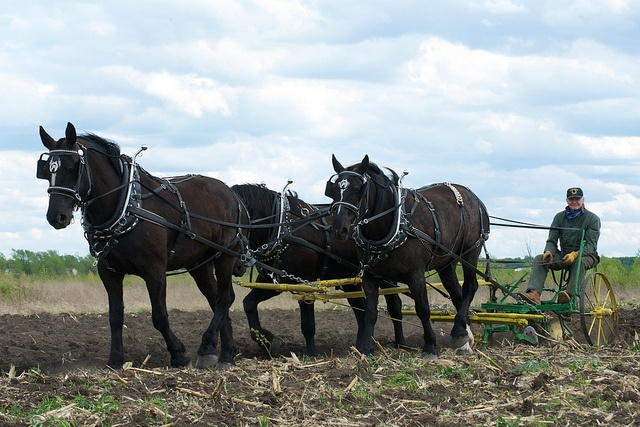Describe the objects in this image and their specific colors. I can see horse in white, black, gray, darkgray, and darkblue tones and people in white, black, gray, and teal tones in this image. 